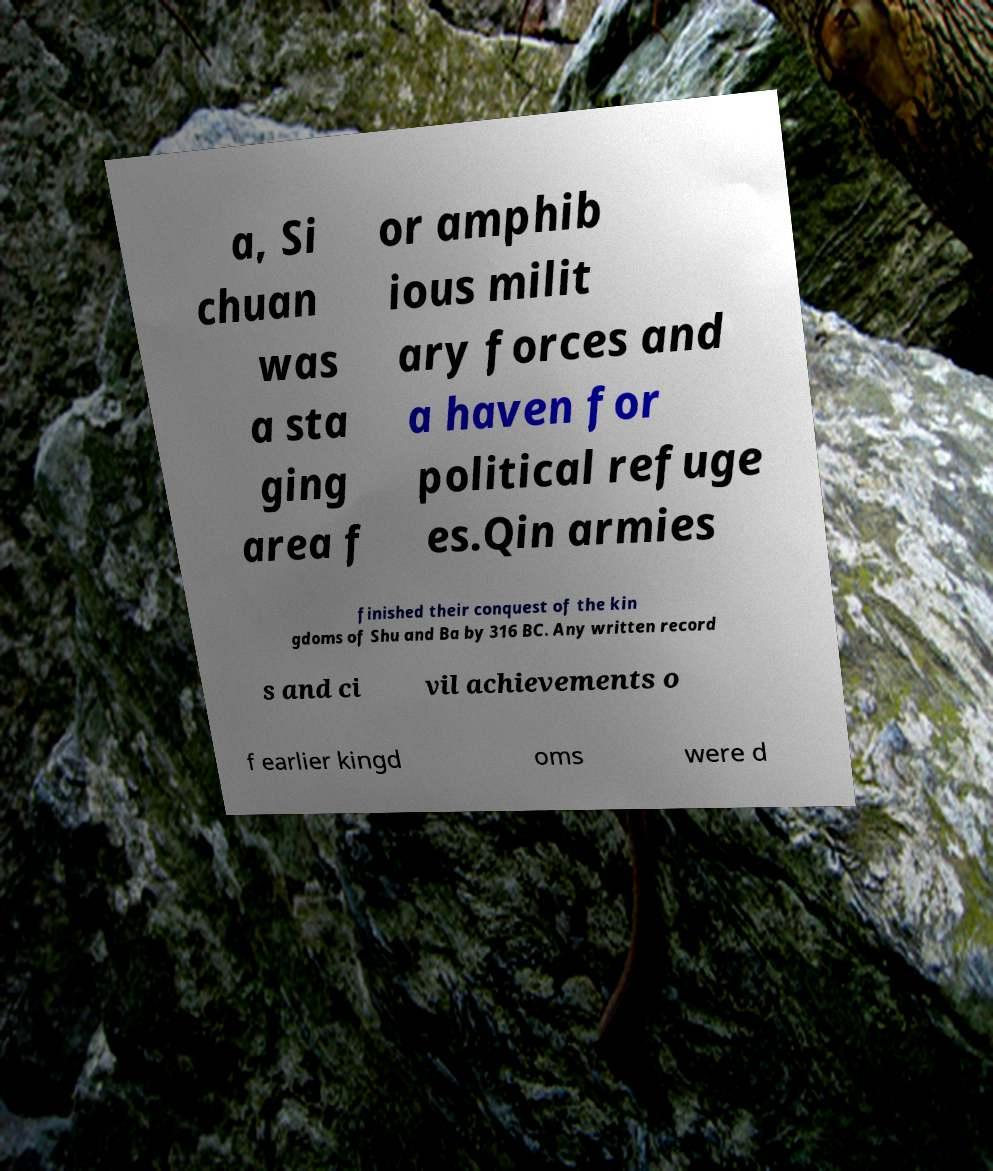Can you accurately transcribe the text from the provided image for me? a, Si chuan was a sta ging area f or amphib ious milit ary forces and a haven for political refuge es.Qin armies finished their conquest of the kin gdoms of Shu and Ba by 316 BC. Any written record s and ci vil achievements o f earlier kingd oms were d 